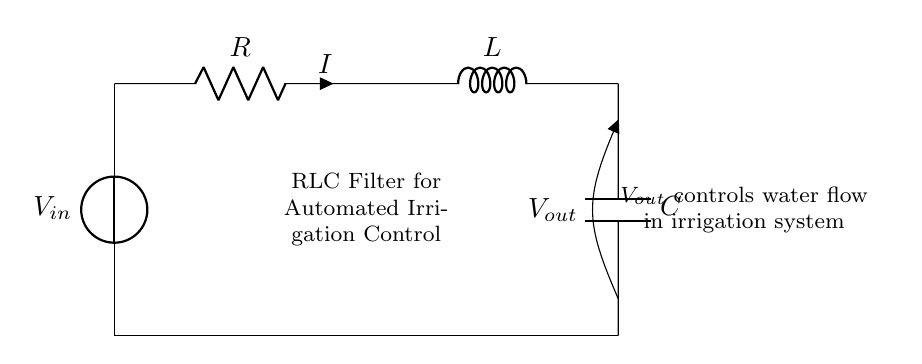What is V in this circuit? V represents the input voltage supplied to the circuit, coming from the voltage source at the top.
Answer: V What is the purpose of the resistor R? The resistor R limits the current flowing through the circuit, helping to manage the power distribution among the components.
Answer: Current limiter What does V out control in this circuit? V out provides a voltage that regulates the water flow in the irrigation system based on the filtered input from the components.
Answer: Water flow Which components are in series in this circuit? The resistor R, the inductor L, and the capacitor C are all connected in a series configuration along the same pathway, allowing the current to flow through each of them sequentially.
Answer: R, L, C What happens when R is increased in value? Increasing the resistance R will reduce the overall current in the circuit, potentially altering the frequency response and the filtering characteristics, which may dampen the output signal.
Answer: Reduced current How does the inductor L affect the circuit? The inductor L opposes changes in current flow due to its property of inductance, which smooths out fluctuations in current and can influence the phase shift between voltage and current.
Answer: Opposes current changes What type of filter does this RLC circuit create? This RLC circuit functions as a band-pass filter, allowing certain frequency ranges of the input signal to pass while attenuating others, which is useful in controlling specific behaviors in automated irrigation systems.
Answer: Band-pass filter 